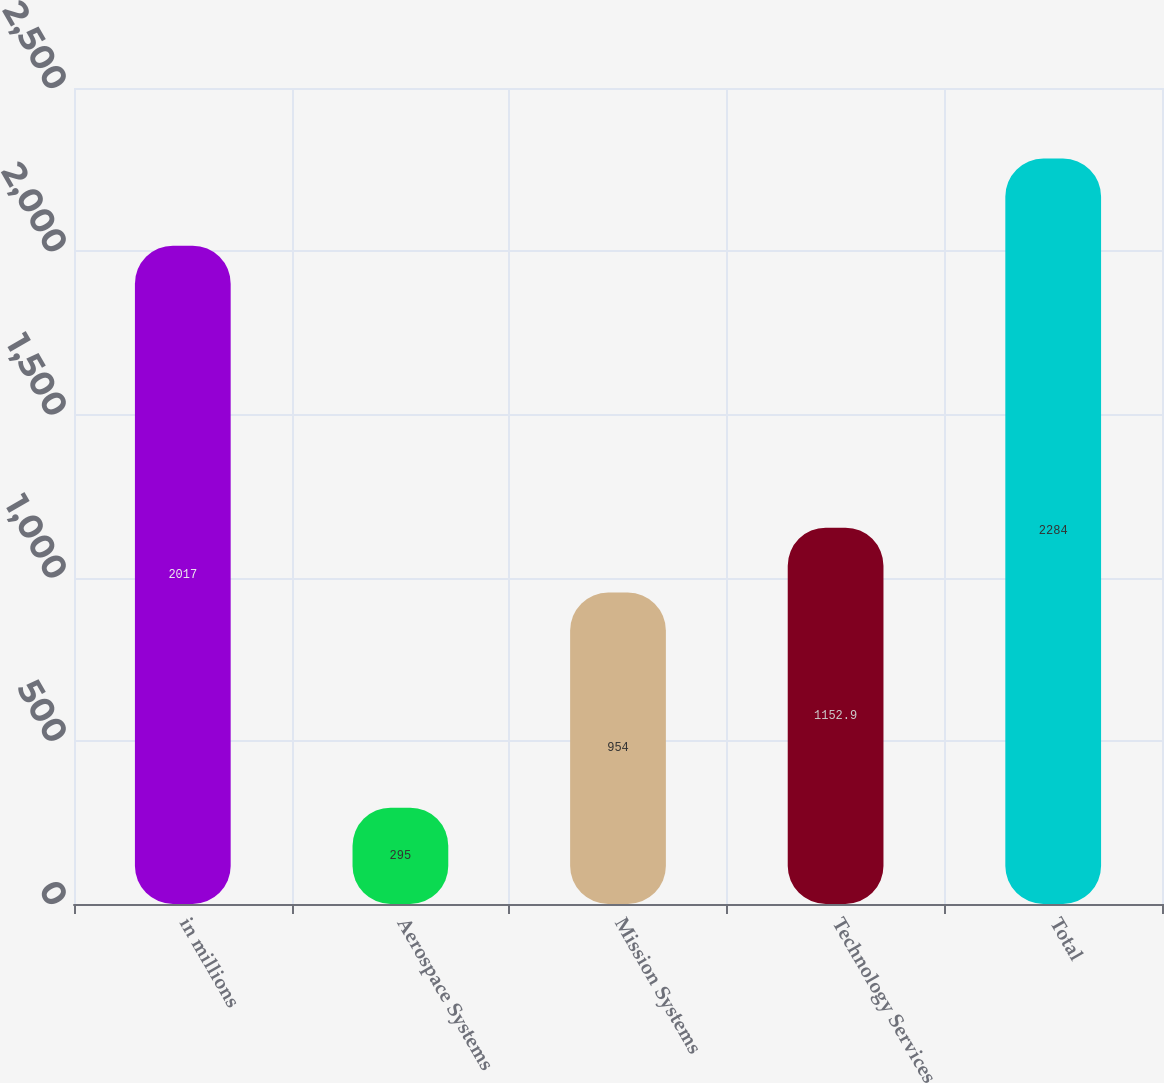Convert chart to OTSL. <chart><loc_0><loc_0><loc_500><loc_500><bar_chart><fcel>in millions<fcel>Aerospace Systems<fcel>Mission Systems<fcel>Technology Services<fcel>Total<nl><fcel>2017<fcel>295<fcel>954<fcel>1152.9<fcel>2284<nl></chart> 